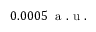Convert formula to latex. <formula><loc_0><loc_0><loc_500><loc_500>0 . 0 0 0 5 \, a . u .</formula> 